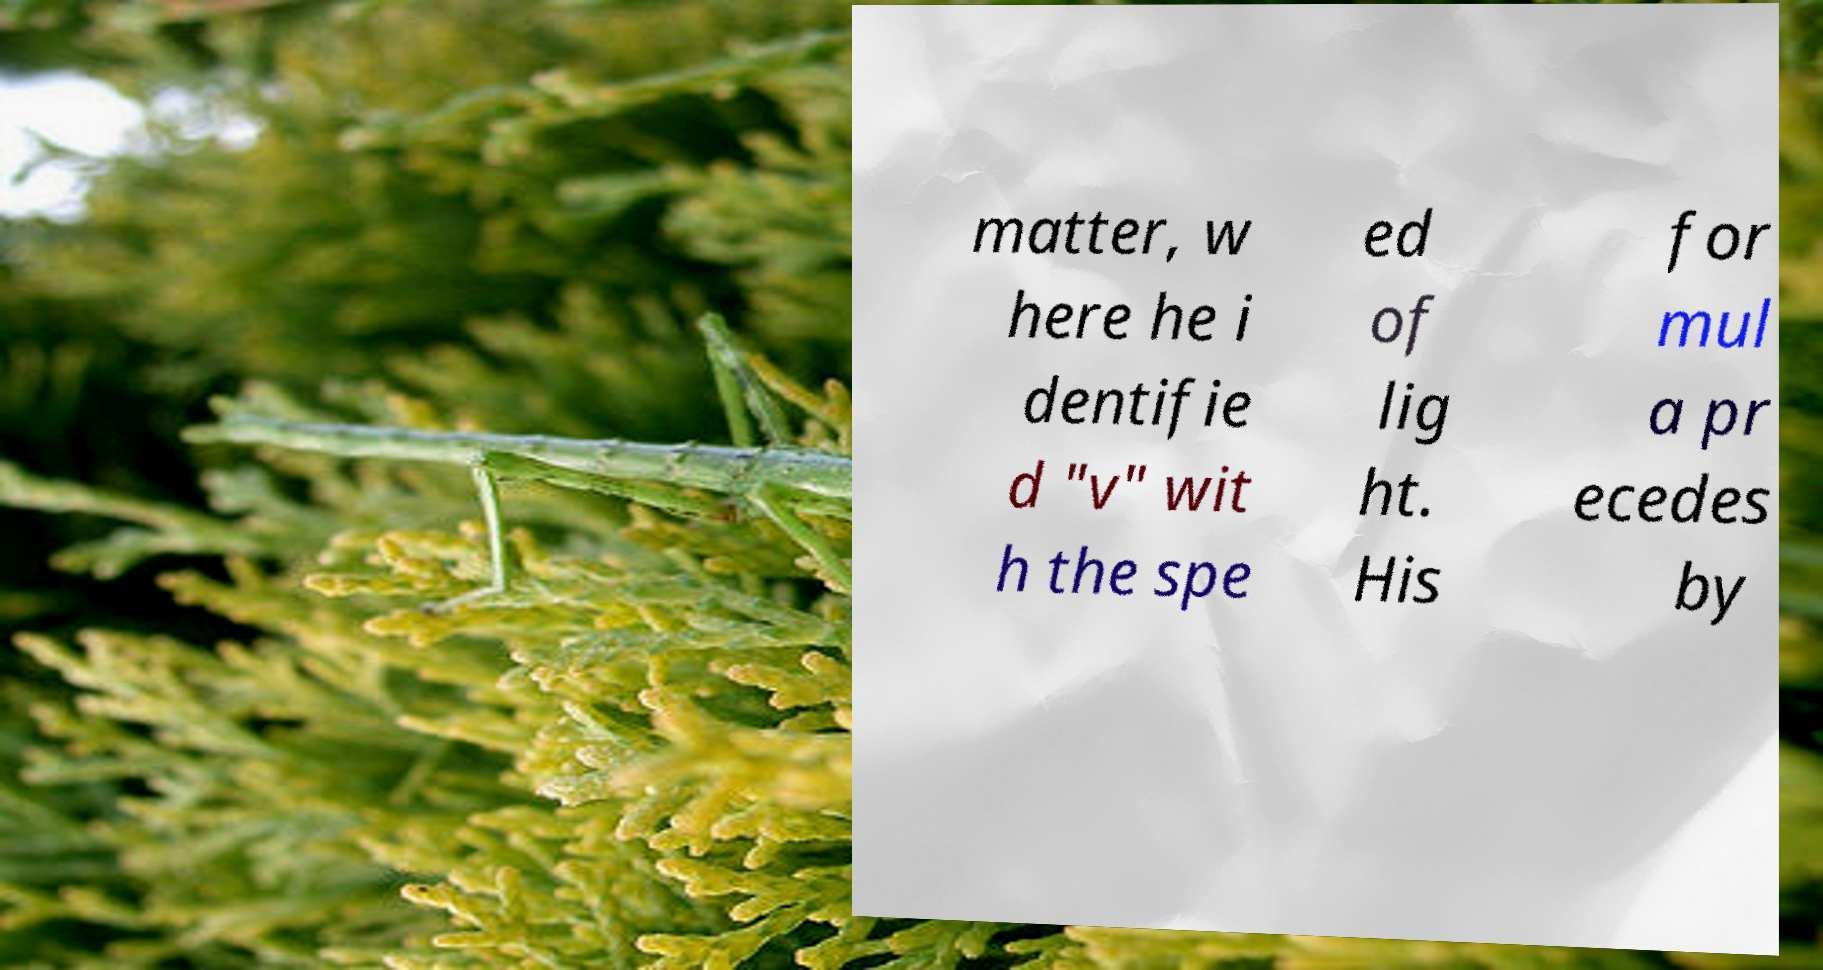Please read and relay the text visible in this image. What does it say? matter, w here he i dentifie d "v" wit h the spe ed of lig ht. His for mul a pr ecedes by 